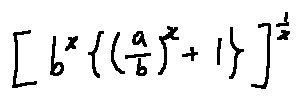Convert formula to latex. <formula><loc_0><loc_0><loc_500><loc_500>[ b ^ { x } \{ ( \frac { a } { b } ) ^ { x } + 1 \} ] ^ { \frac { 1 } { x } }</formula> 